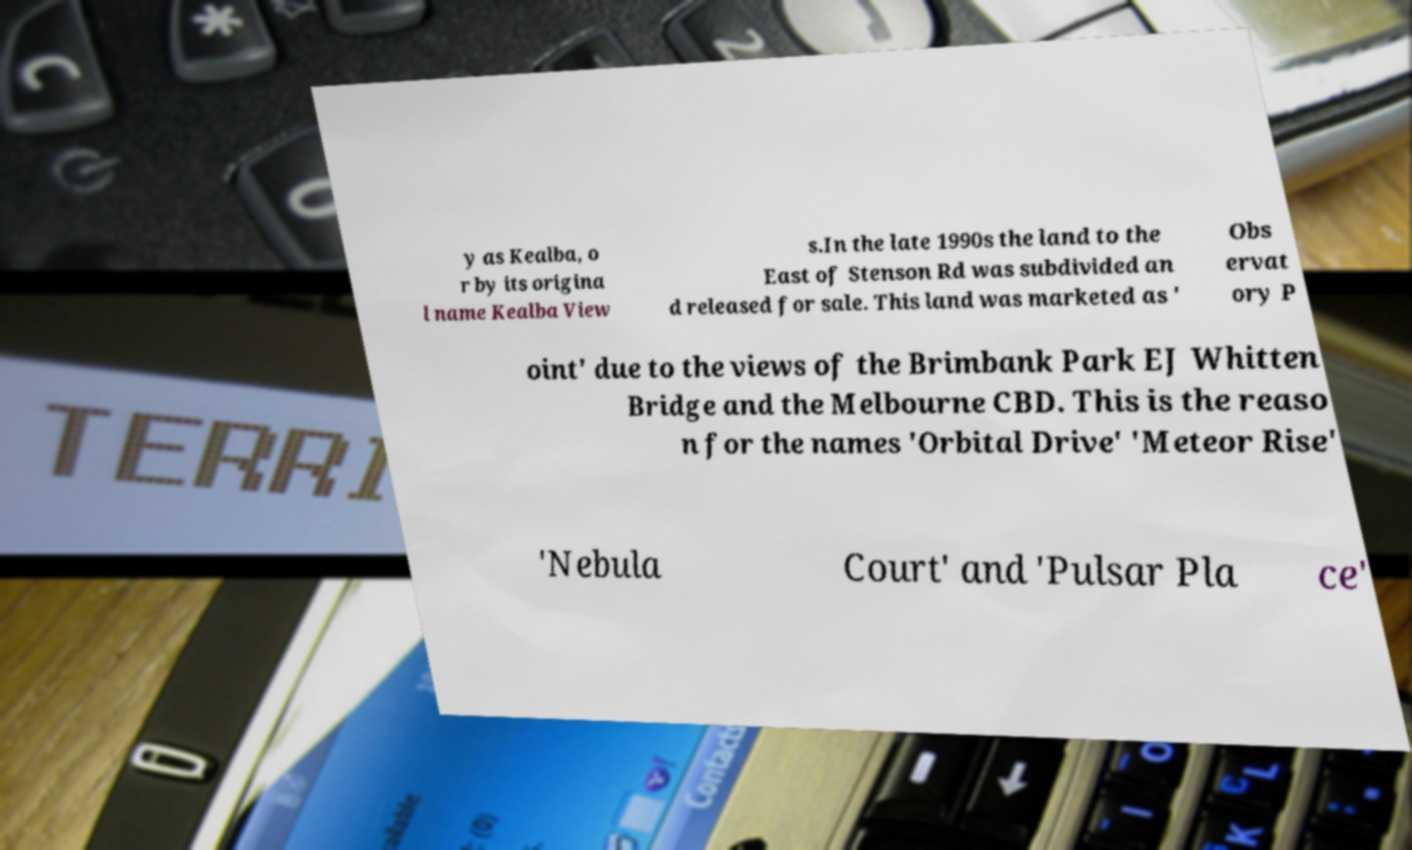For documentation purposes, I need the text within this image transcribed. Could you provide that? y as Kealba, o r by its origina l name Kealba View s.In the late 1990s the land to the East of Stenson Rd was subdivided an d released for sale. This land was marketed as ' Obs ervat ory P oint' due to the views of the Brimbank Park EJ Whitten Bridge and the Melbourne CBD. This is the reaso n for the names 'Orbital Drive' 'Meteor Rise' 'Nebula Court' and 'Pulsar Pla ce' 